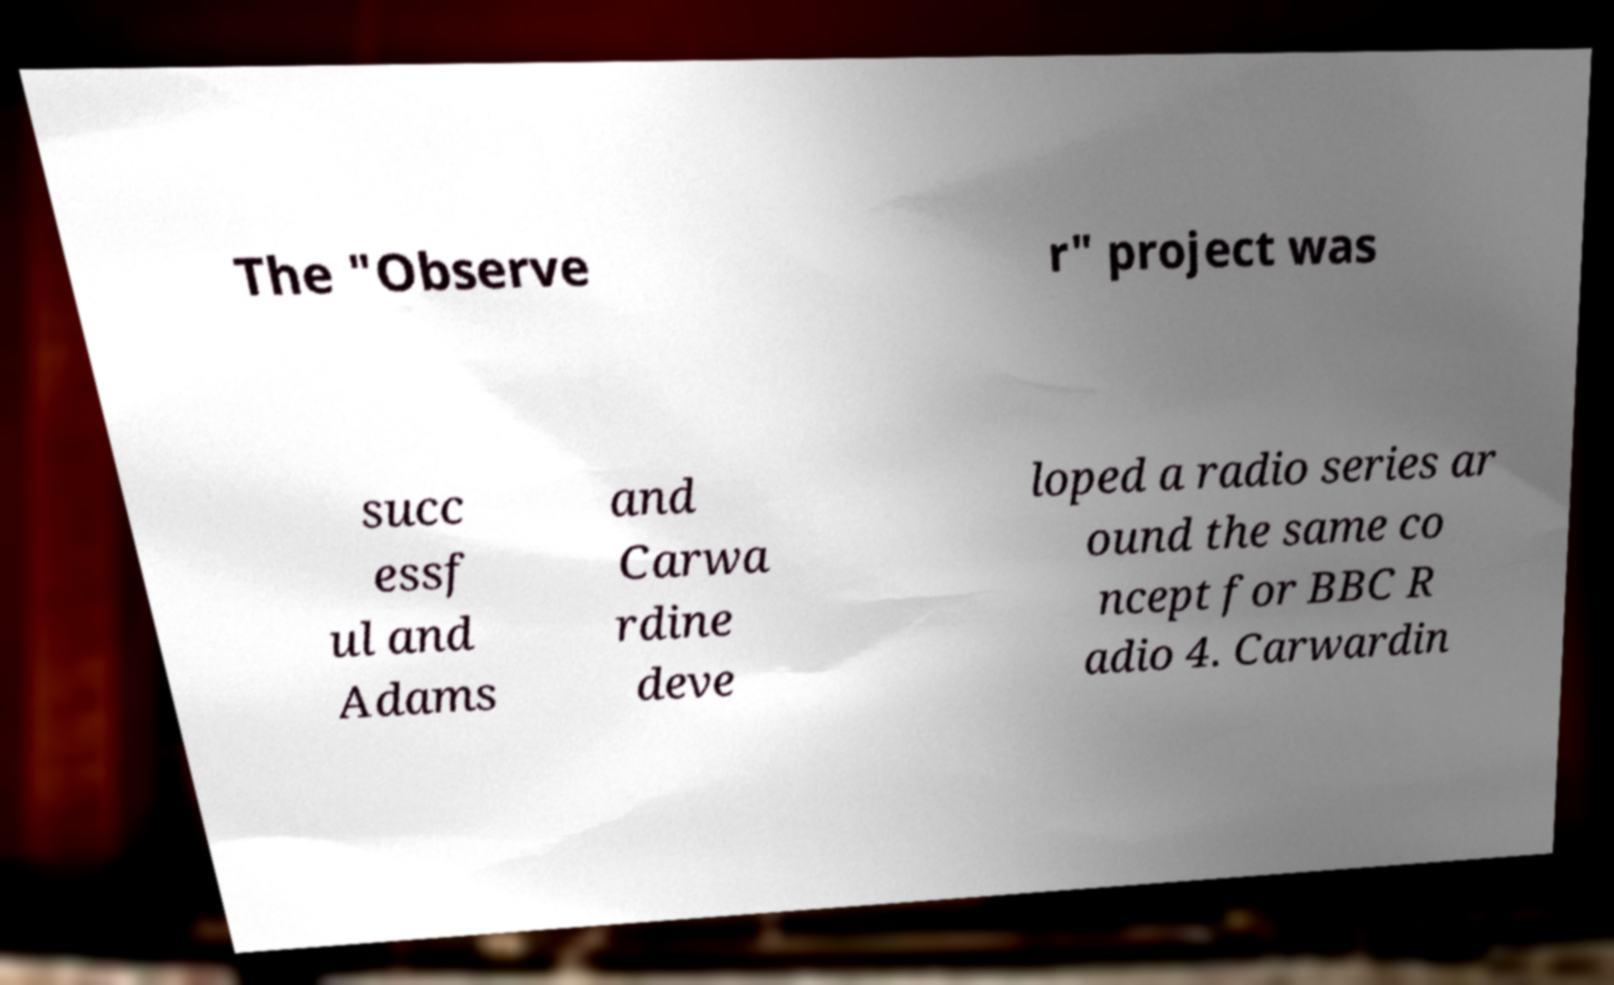Could you extract and type out the text from this image? The "Observe r" project was succ essf ul and Adams and Carwa rdine deve loped a radio series ar ound the same co ncept for BBC R adio 4. Carwardin 